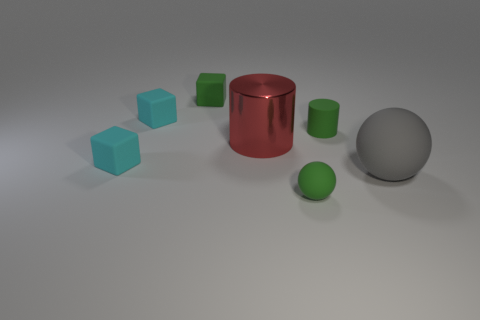Subtract all cyan cubes. How many were subtracted if there are1cyan cubes left? 1 Subtract all green cubes. How many cubes are left? 2 Subtract all purple cylinders. How many cyan cubes are left? 2 Subtract all green cylinders. How many cylinders are left? 1 Subtract all blue blocks. Subtract all purple cylinders. How many blocks are left? 3 Subtract all red cylinders. Subtract all large gray objects. How many objects are left? 5 Add 4 tiny cyan cubes. How many tiny cyan cubes are left? 6 Add 5 large gray shiny objects. How many large gray shiny objects exist? 5 Add 3 small things. How many objects exist? 10 Subtract 1 green cylinders. How many objects are left? 6 